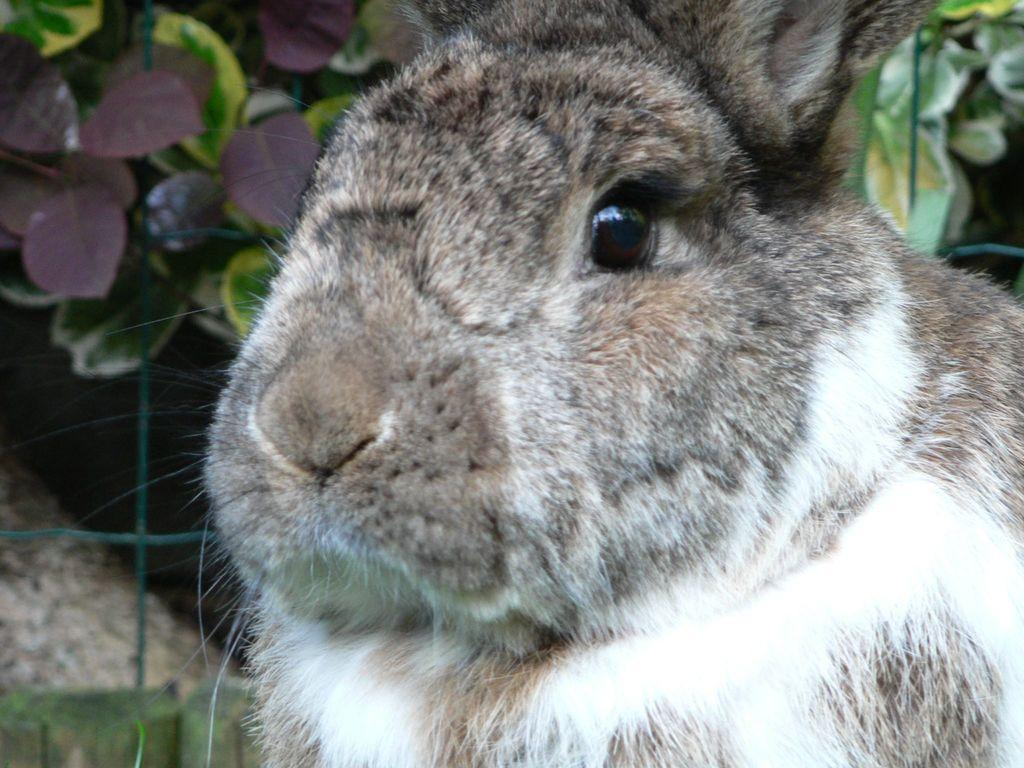What is the main subject of the image? There is a rat in the center of the image. What can be seen in the background of the image? There are leaves and a mesh in the background of the image. What type of apparel is the rat wearing in the image? There is no apparel present on the rat in the image. Can you describe the downtown area visible in the image? There is no downtown area visible in the image; it features a rat and a background with leaves and a mesh. 